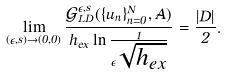Convert formula to latex. <formula><loc_0><loc_0><loc_500><loc_500>\lim _ { ( \epsilon , s ) \rightarrow ( 0 , 0 ) } \frac { \mathcal { G } _ { L D } ^ { \epsilon , s } ( \{ u _ { n } \} _ { n = 0 } ^ { N } , \vec { A } ) } { h _ { e x } \ln \frac { 1 } { \epsilon \sqrt { h _ { e x } } } } = \frac { | D | } { 2 } .</formula> 